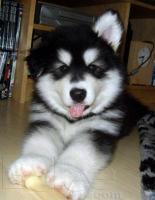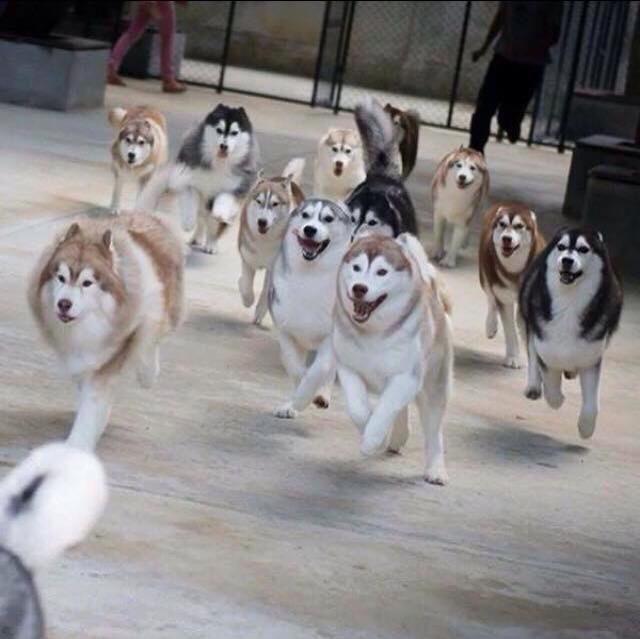The first image is the image on the left, the second image is the image on the right. For the images shown, is this caption "One image has one dog and the other image has a pack of dogs." true? Answer yes or no. Yes. The first image is the image on the left, the second image is the image on the right. For the images shown, is this caption "A sled is being pulled over the snow by a team of dogs in one of the images." true? Answer yes or no. No. 